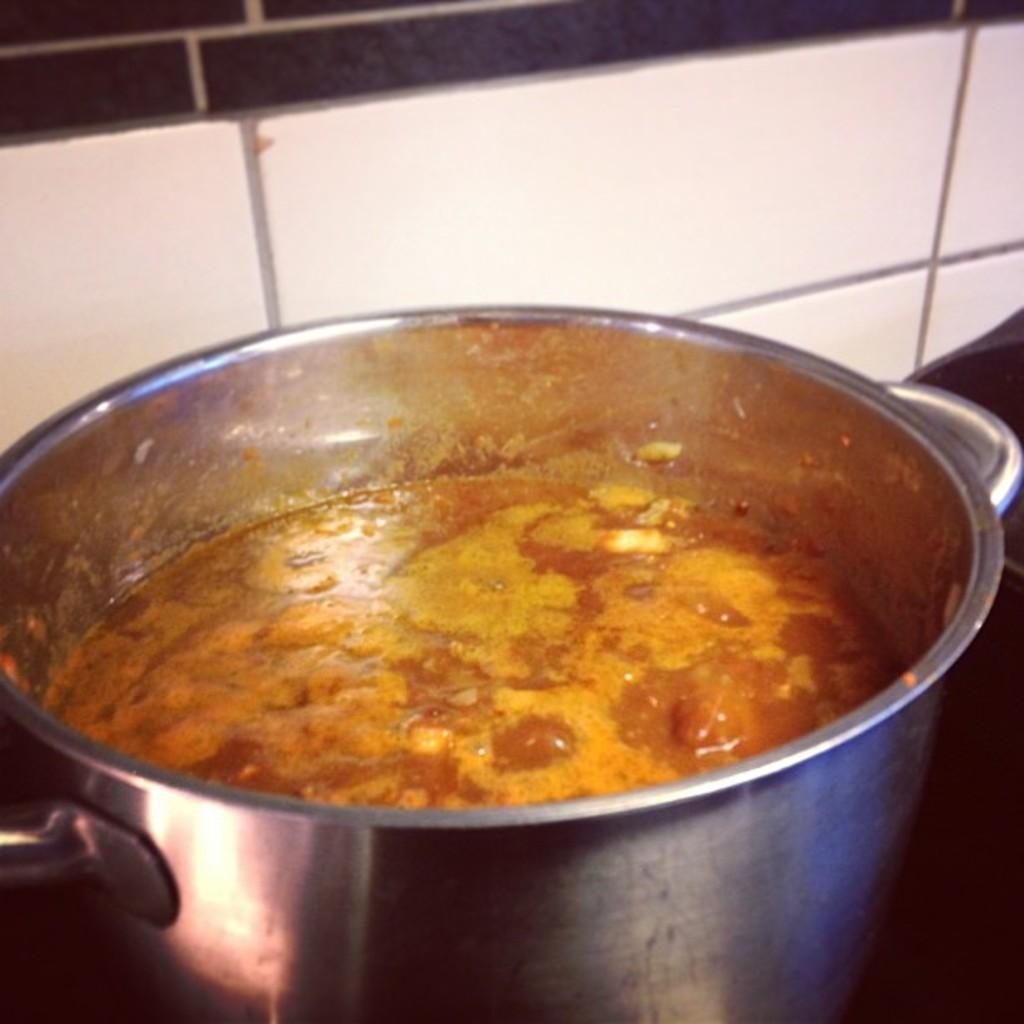What type of cooking equipment is present in the image? There is a cooking vessel in the image. What is inside the cooking vessel? The cooking vessel contains liquid. What can be seen in the background of the image? There is a tile wall in the background of the image. What type of tin can be seen in the image? There is no tin present in the image. What is the secretary doing in the image? There is no secretary present in the image. 